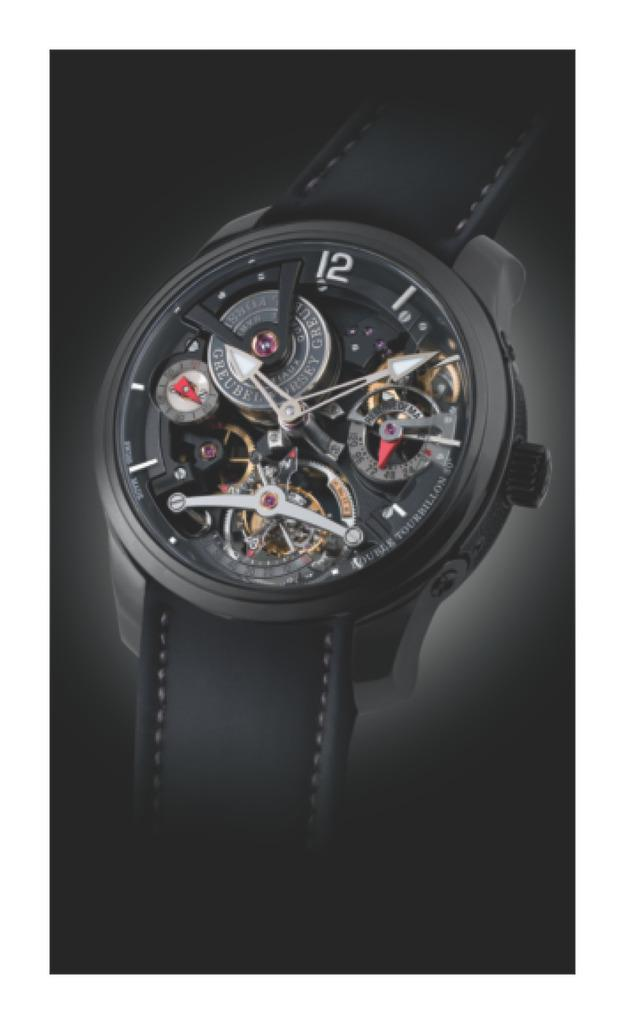<image>
Present a compact description of the photo's key features. A black watch has one number on the face of 12. 